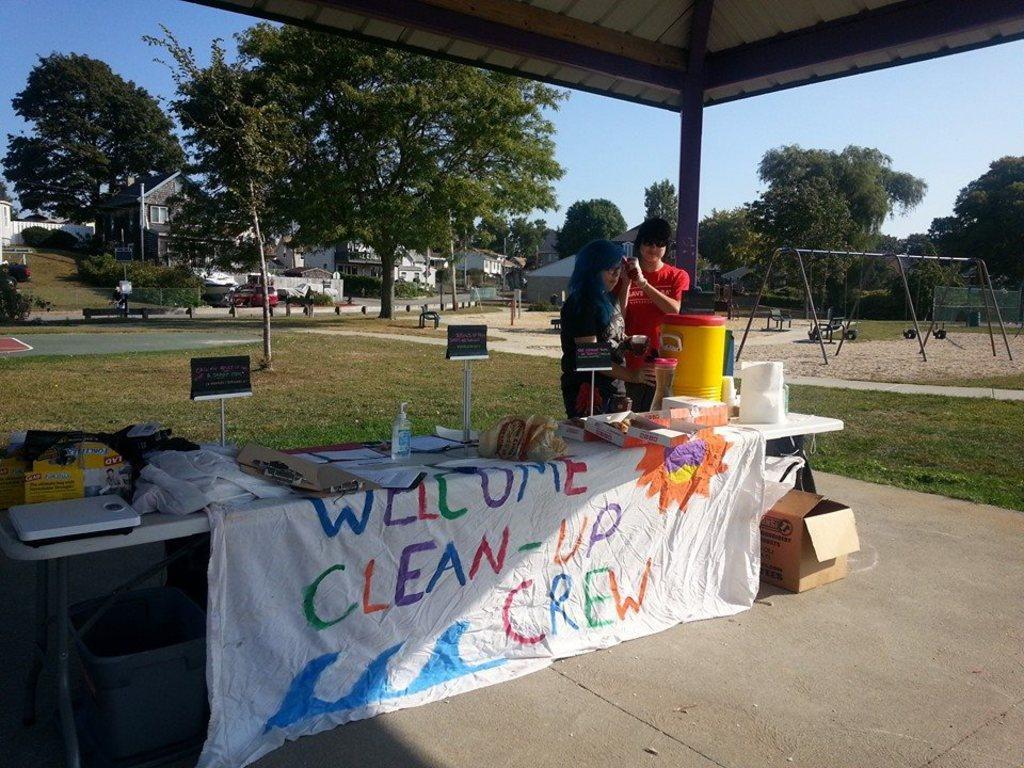Could you give a brief overview of what you see in this image? In this image there are two persons who are standing in front of them there is one table and that table is covered with a white cloth and under that table. On the left side there is one dustbin and on the right side there is one box, on that table there are some clothes hand wash and some containers are there and on the top of the image there are some trees, buildings, vehicles are there. On the right side there is some grass and on the top of the image there is sky. 